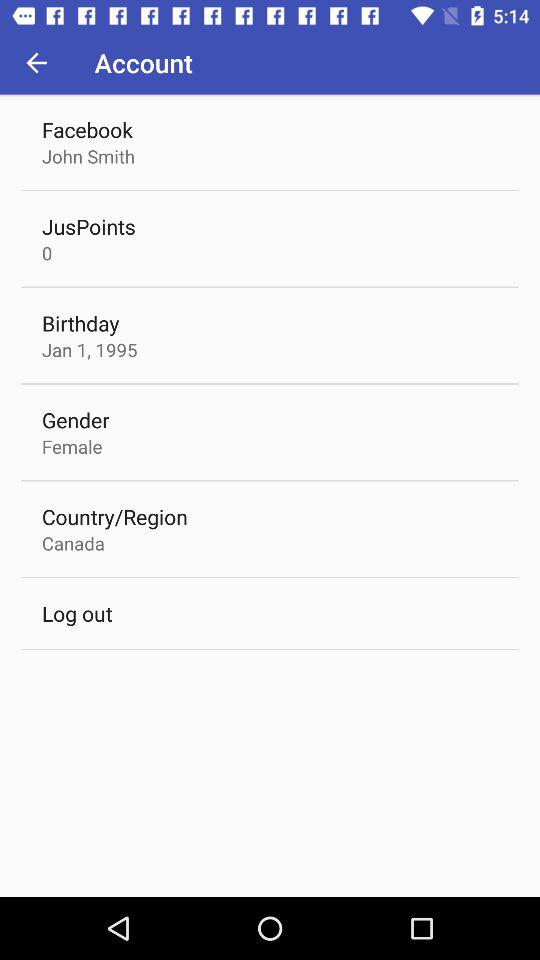What is the name of the country? The name of the country is Canada. 